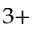<formula> <loc_0><loc_0><loc_500><loc_500>^ { 3 + }</formula> 